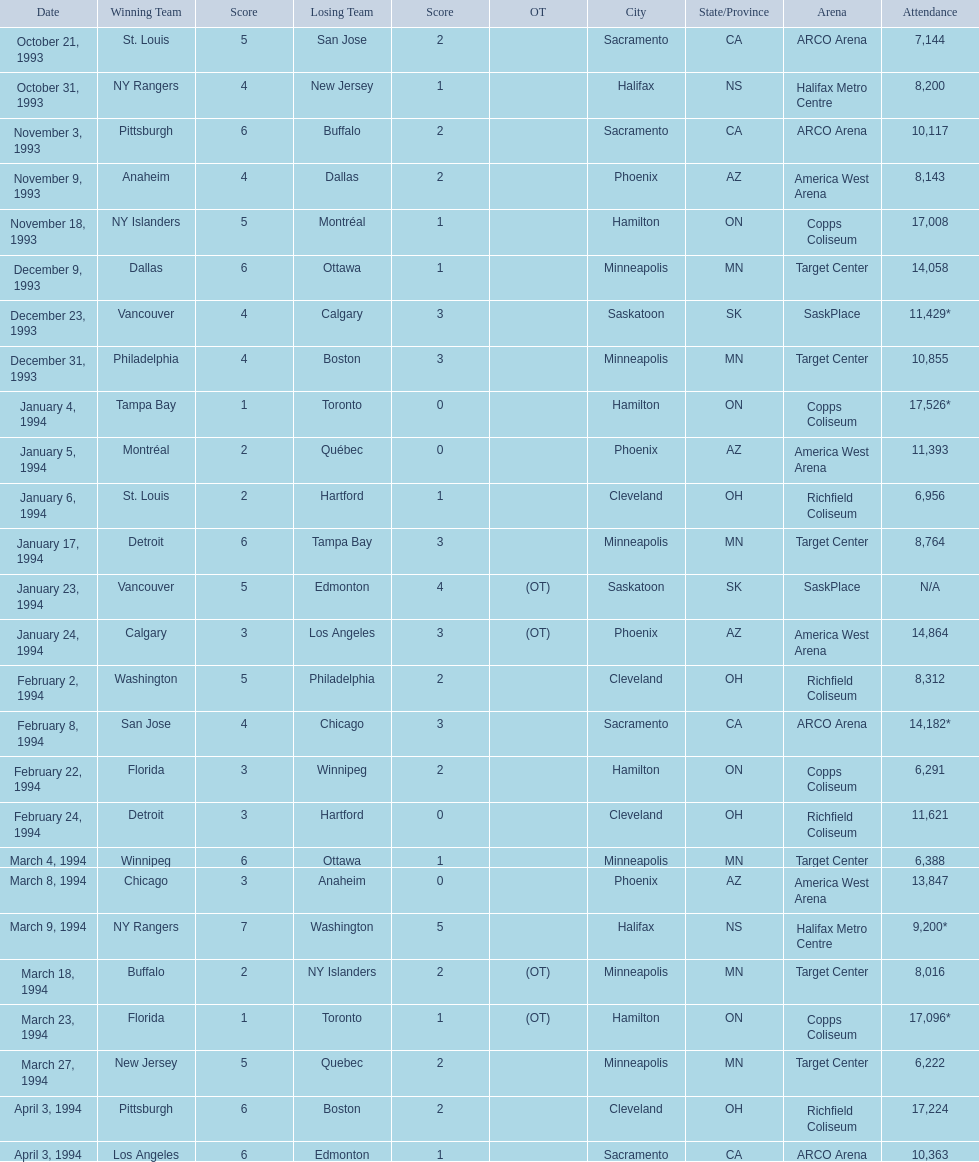What were the attendance figures for the 1993-94 nhl season? 7,144, 8,200, 10,117, 8,143, 17,008, 14,058, 11,429*, 10,855, 17,526*, 11,393, 6,956, 8,764, N/A, 14,864, 8,312, 14,182*, 6,291, 11,621, 6,388, 13,847, 9,200*, 8,016, 17,096*, 6,222, 17,224, 10,363. Which one had the highest attendance? 17,526*. On which date did this highest attendance take place? January 4, 1994. 